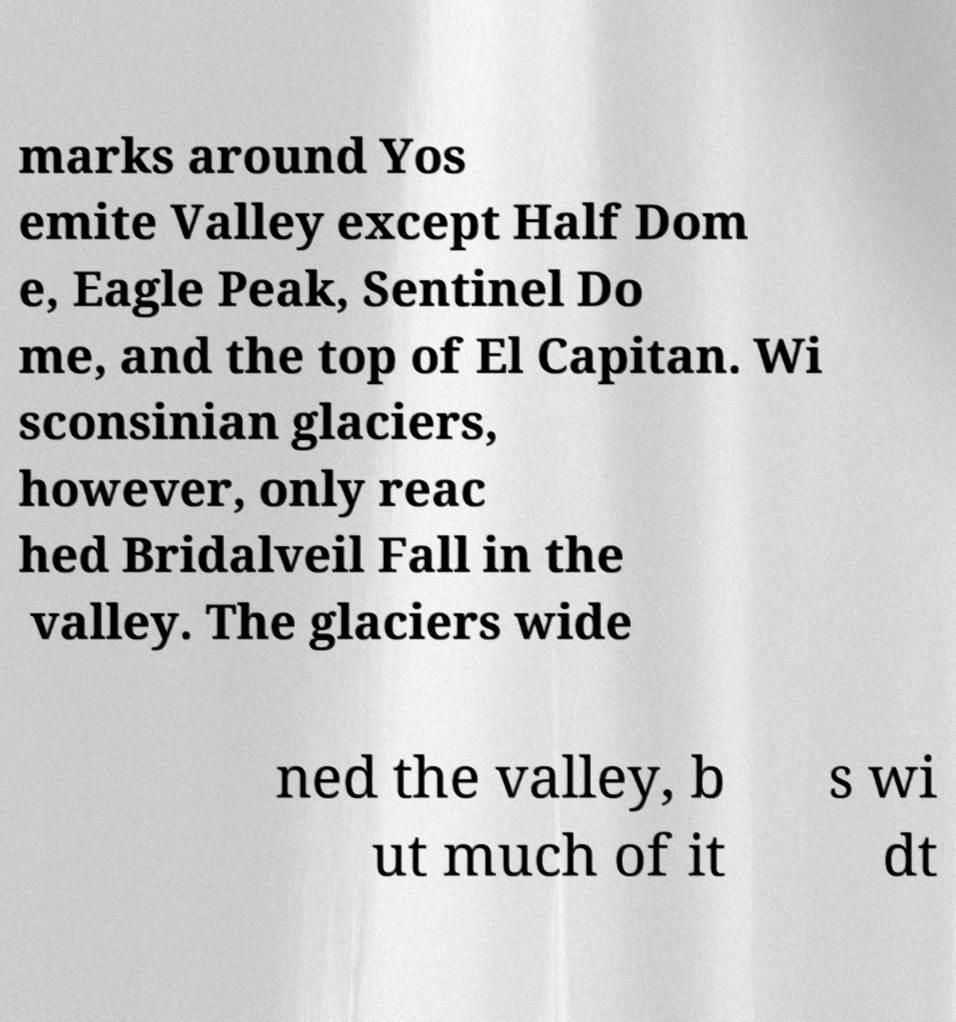Please read and relay the text visible in this image. What does it say? marks around Yos emite Valley except Half Dom e, Eagle Peak, Sentinel Do me, and the top of El Capitan. Wi sconsinian glaciers, however, only reac hed Bridalveil Fall in the valley. The glaciers wide ned the valley, b ut much of it s wi dt 